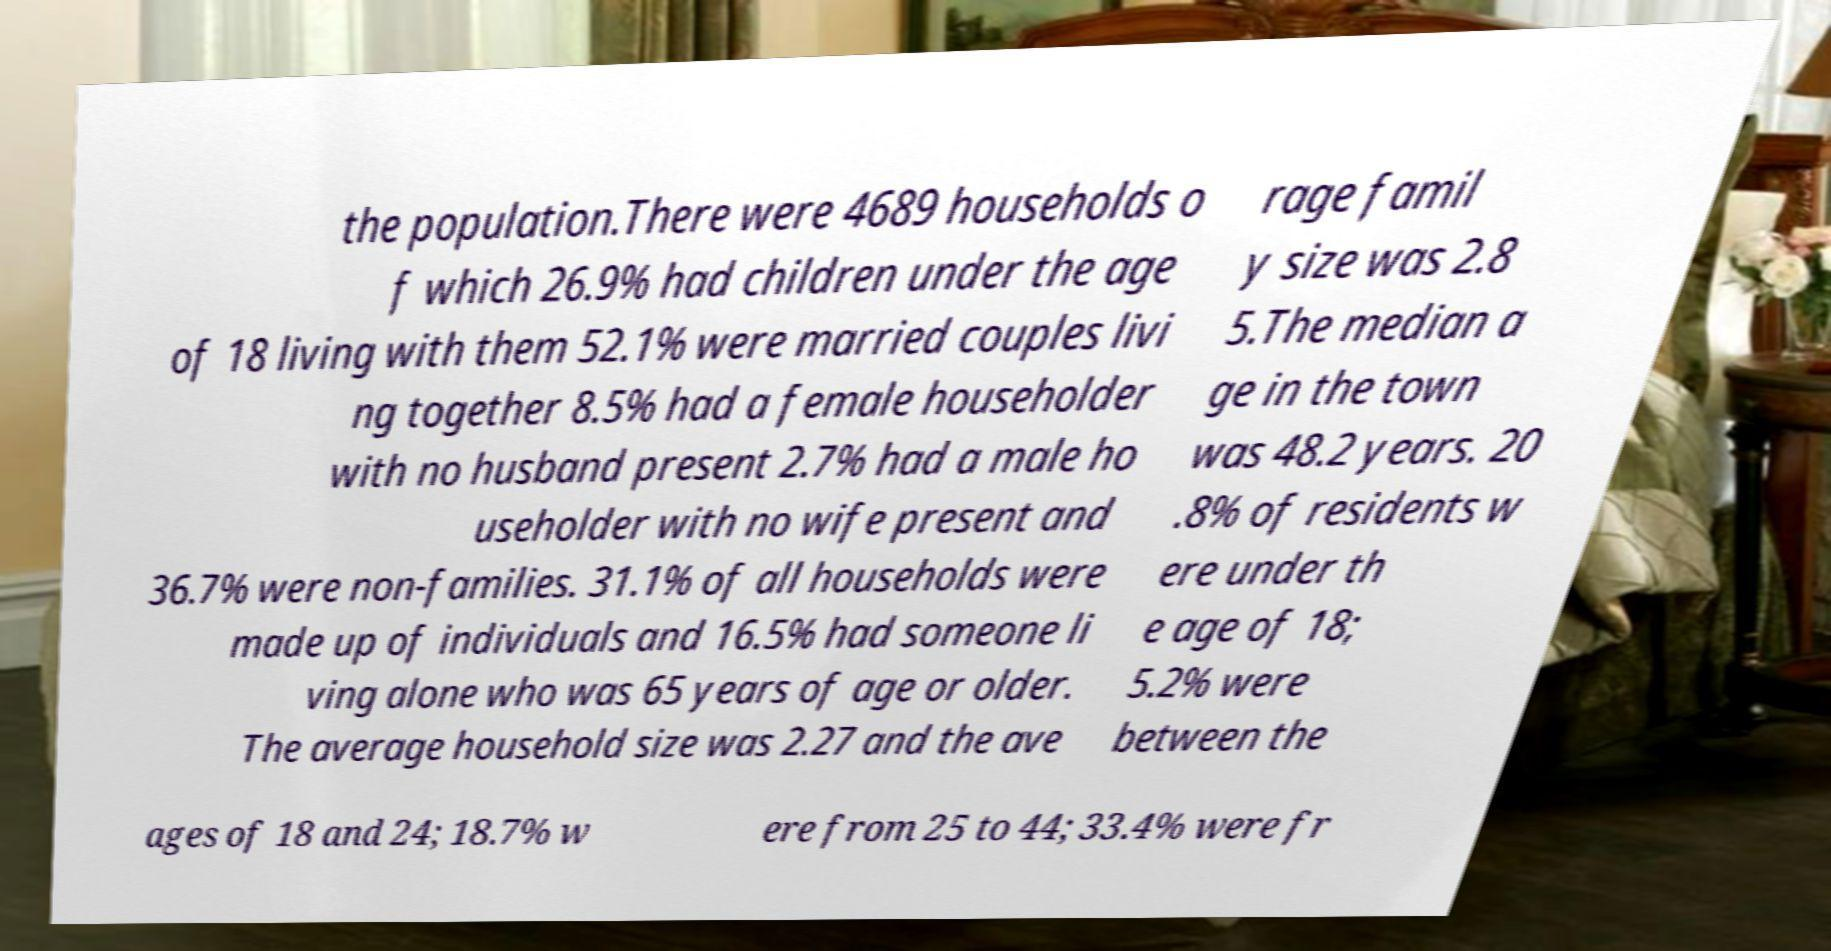Could you extract and type out the text from this image? the population.There were 4689 households o f which 26.9% had children under the age of 18 living with them 52.1% were married couples livi ng together 8.5% had a female householder with no husband present 2.7% had a male ho useholder with no wife present and 36.7% were non-families. 31.1% of all households were made up of individuals and 16.5% had someone li ving alone who was 65 years of age or older. The average household size was 2.27 and the ave rage famil y size was 2.8 5.The median a ge in the town was 48.2 years. 20 .8% of residents w ere under th e age of 18; 5.2% were between the ages of 18 and 24; 18.7% w ere from 25 to 44; 33.4% were fr 